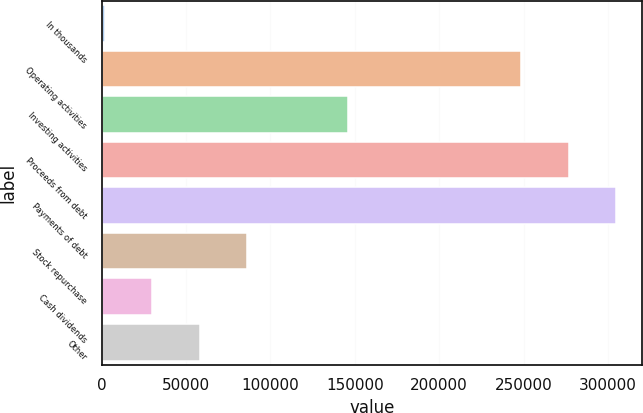Convert chart to OTSL. <chart><loc_0><loc_0><loc_500><loc_500><bar_chart><fcel>In thousands<fcel>Operating activities<fcel>Investing activities<fcel>Proceeds from debt<fcel>Payments of debt<fcel>Stock repurchase<fcel>Cash dividends<fcel>Other<nl><fcel>2011<fcel>248626<fcel>146182<fcel>276745<fcel>304864<fcel>86368.3<fcel>30130.1<fcel>58249.2<nl></chart> 